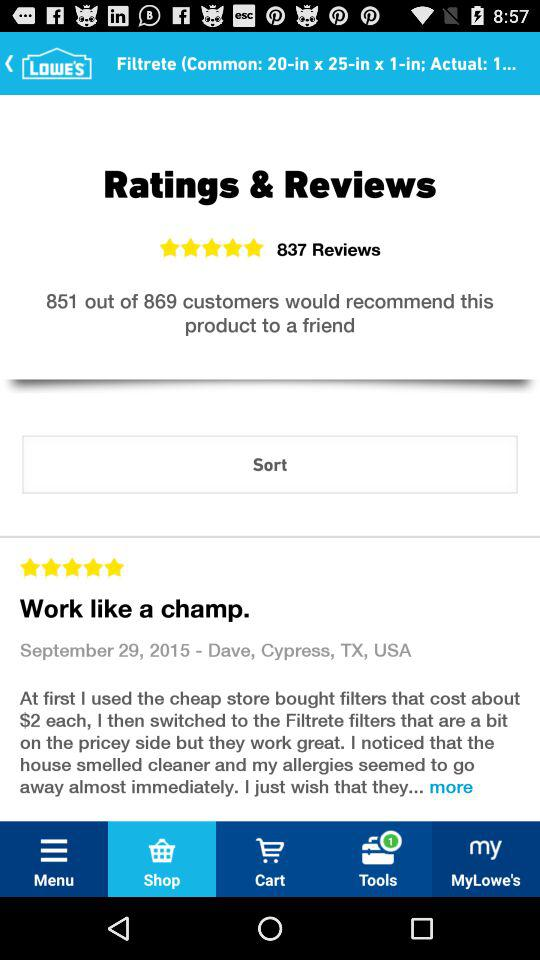What is the name of the product?
When the provided information is insufficient, respond with <no answer>. <no answer> 